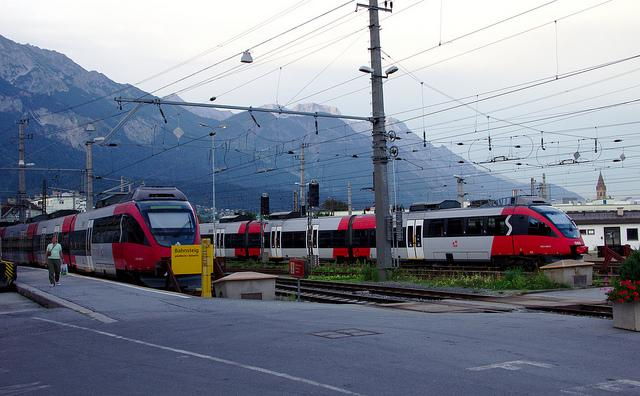What helps for transponders to communicate with the cab and train control systems?

Choices:
A) network
B) wire
C) signal
D) cab signal 